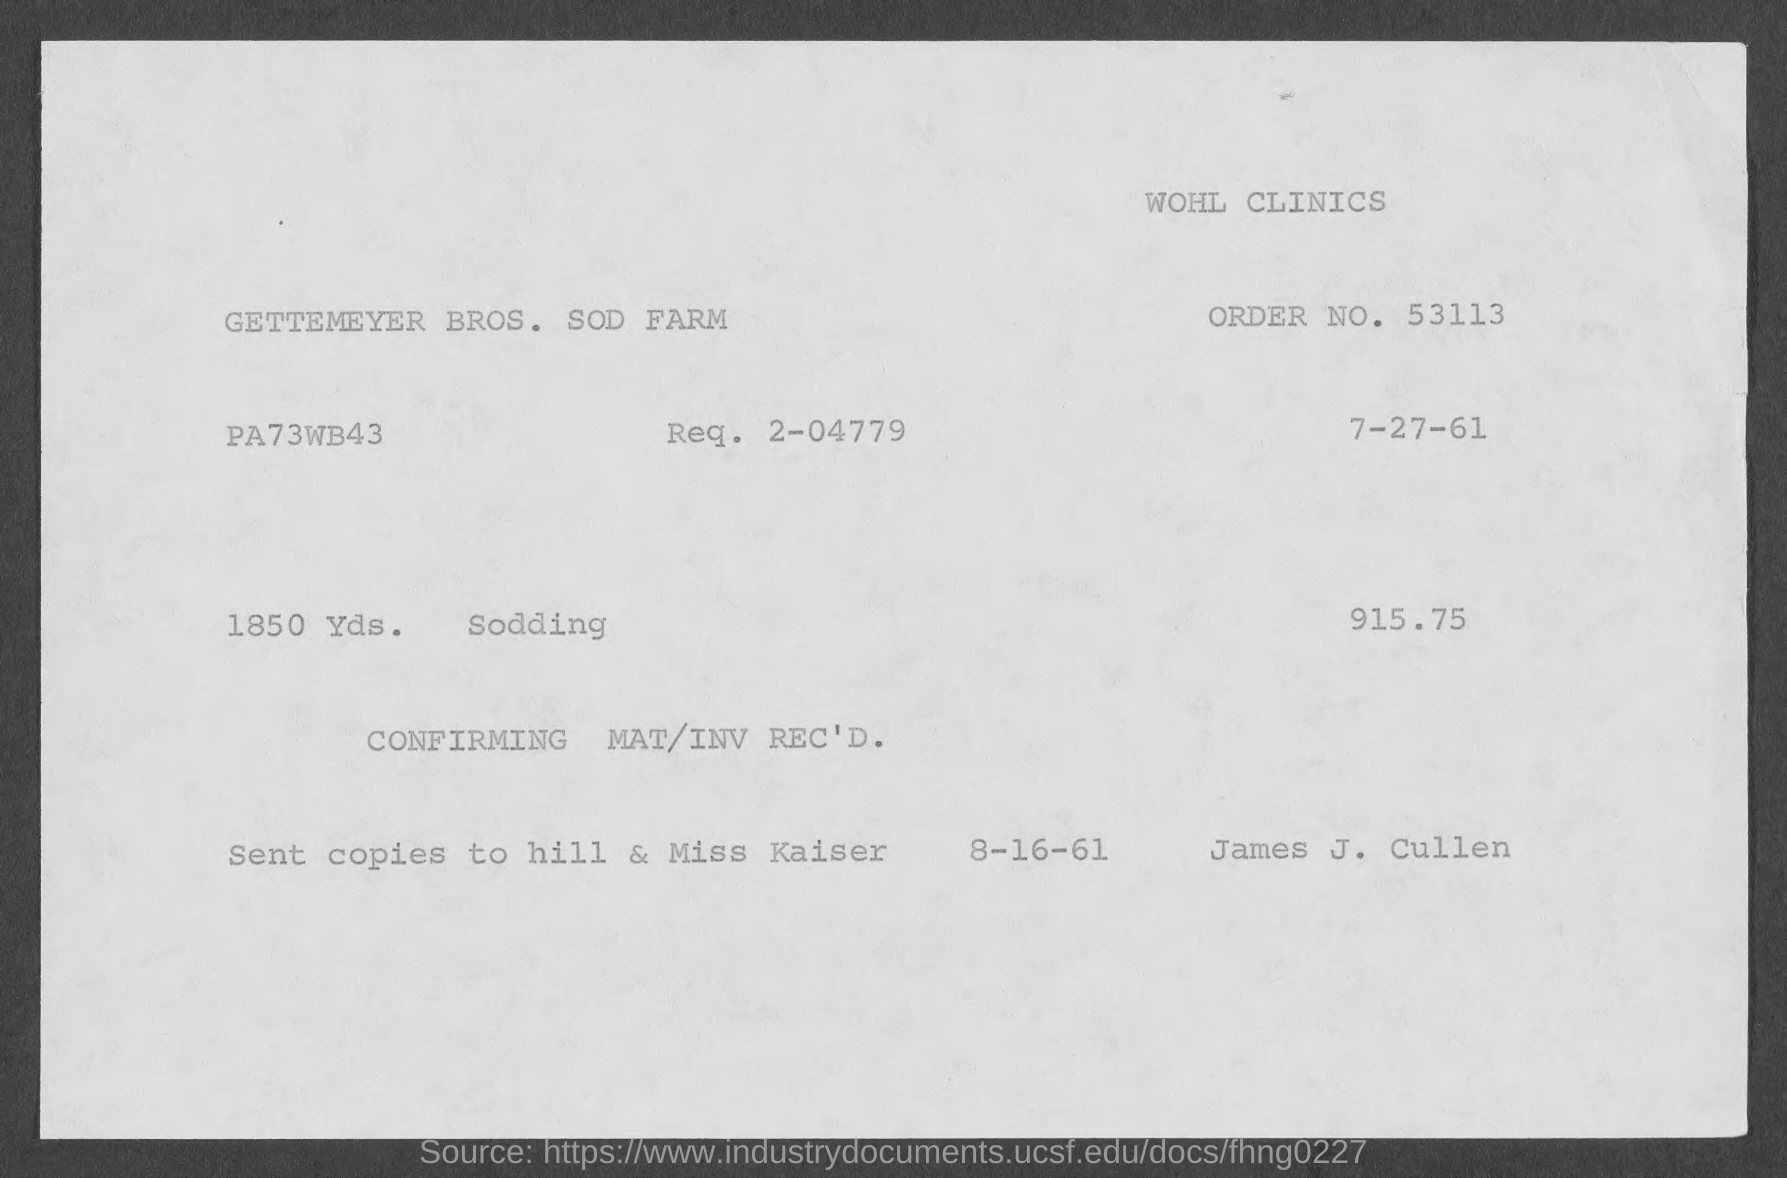What is the issued date of the invoice?
Provide a short and direct response. 7-27-61. What is the Order No. given in the invoice?
Keep it short and to the point. 53113. What is the Req. No. given in the invoice?
Your answer should be compact. 2-04779. What is the total invoice amount as per the document?
Keep it short and to the point. 915.75. 